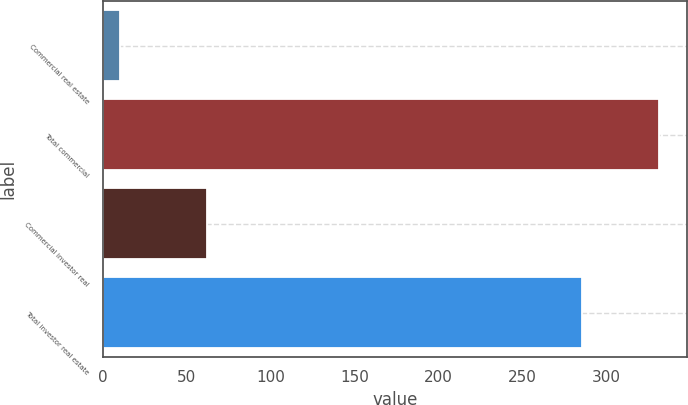Convert chart. <chart><loc_0><loc_0><loc_500><loc_500><bar_chart><fcel>Commercial real estate<fcel>Total commercial<fcel>Commercial investor real<fcel>Total investor real estate<nl><fcel>10<fcel>331<fcel>62<fcel>285<nl></chart> 